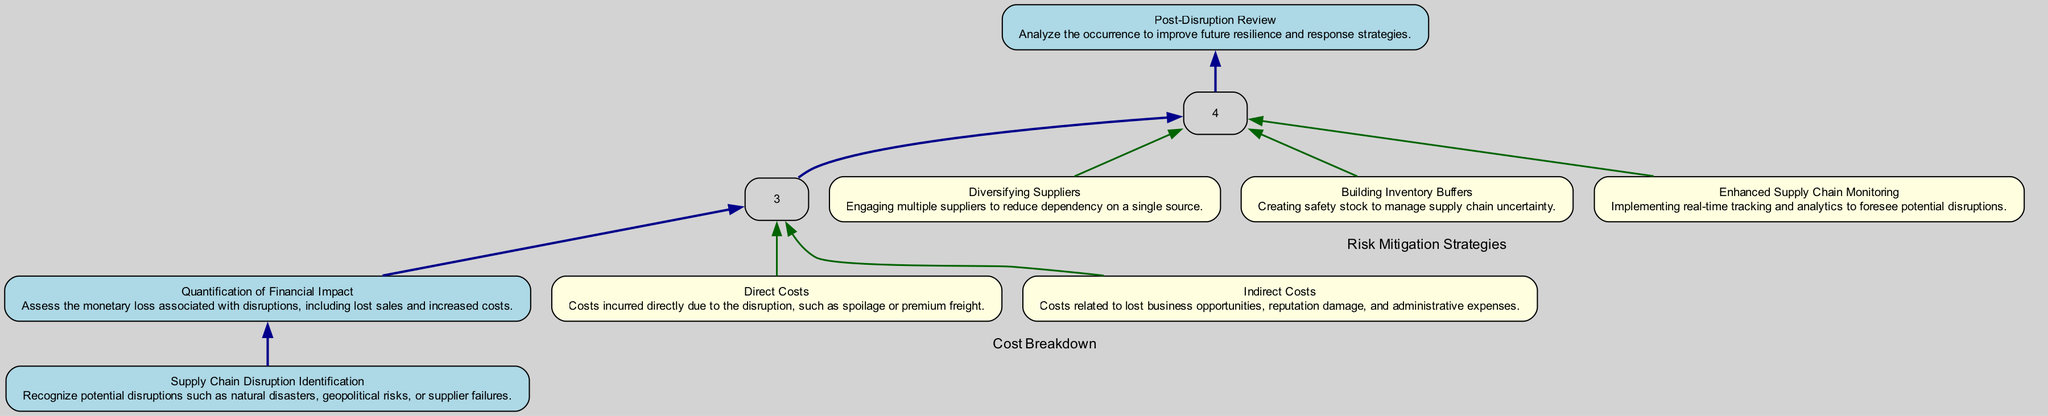What is the first step in the analysis process? The first step is labeled "Supply Chain Disruption Identification," which indicates that recognizing potential disruptions is the starting point of the analysis.
Answer: Supply Chain Disruption Identification How many main elements are present in the diagram? There are five main elements shown in the diagram. These elements include disruption identification, financial impact quantification, cost breakdown, risk mitigation strategies, and post-disruption review.
Answer: Five What type of costs are included in the cost breakdown? The cost breakdown includes two types of costs: Direct Costs and Indirect Costs. This is specified under the main element "Cost Breakdown."
Answer: Direct Costs, Indirect Costs Which risk mitigation strategy involves creating safety stock? The strategy that involves creating safety stock is "Building Inventory Buffers." This is one of the sub-elements under the "Risk Mitigation Strategies" category.
Answer: Building Inventory Buffers What is the relationship between quantifying financial impact and cost breakdown? The relationship is that "Quantification of Financial Impact" leads directly to "Cost Breakdown." This indicates that the assessment of monetary loss will provide insights into how costs are categorized and analyzed.
Answer: Leads to What steps follow after identifying supply chain disruptions? After identifying supply chain disruptions, the next step is to quantify the financial impact, followed by breaking down the costs, then devising risk mitigation strategies, and finally conducting a post-disruption review.
Answer: Quantification of Financial Impact Which sub-element is related to monitoring supply chain conditions? The sub-element related to monitoring supply chain conditions is "Enhanced Supply Chain Monitoring." This strategy is aimed at implementing real-time tracking to foresee potential disruptions.
Answer: Enhanced Supply Chain Monitoring What are the two categories of costs defined in the diagram? The two categories of costs defined in the diagram are Direct Costs and Indirect Costs, which are specifically categorized under the "Cost Breakdown" element.
Answer: Direct Costs, Indirect Costs In what direction do the edges flow from "Risk Mitigation Strategies" to "Post-Disruption Review"? The edges flow in a downward direction, indicating that once risk mitigation strategies have been proposed and implemented, the next logical step is to conduct a post-disruption review.
Answer: Downward 